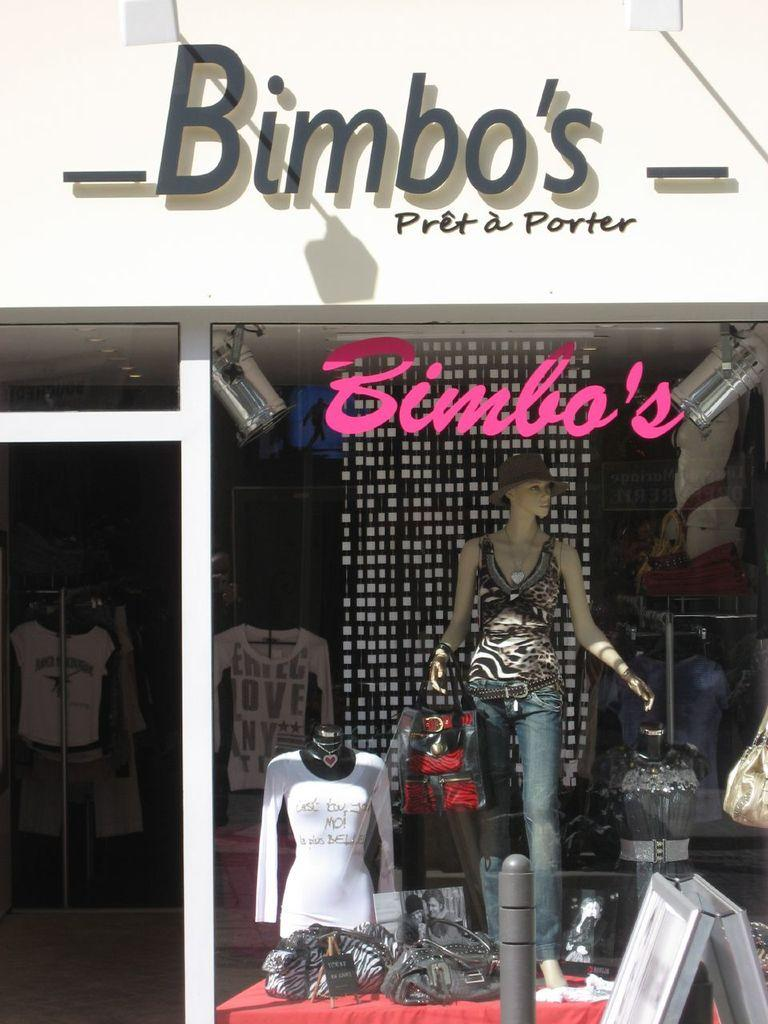<image>
Render a clear and concise summary of the photo. Store front that says Bimbo's on the top. 